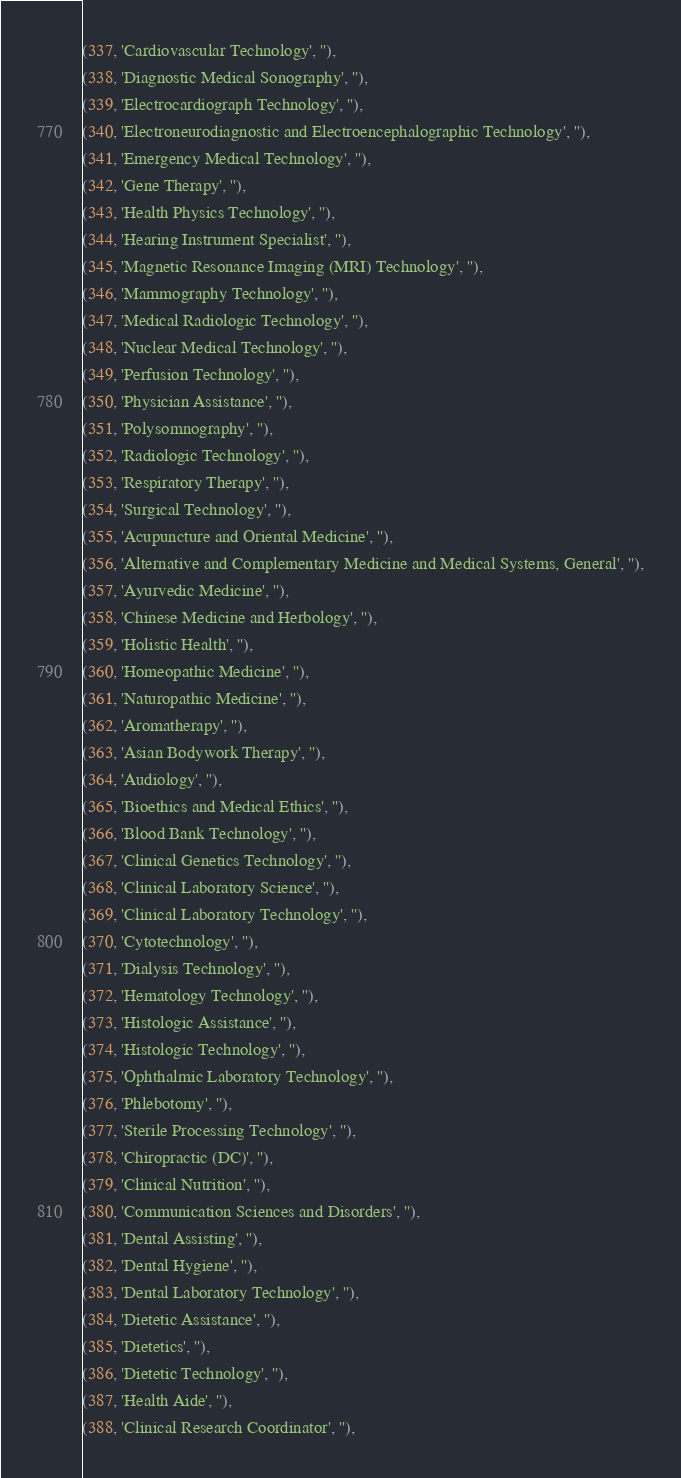Convert code to text. <code><loc_0><loc_0><loc_500><loc_500><_SQL_>(337, 'Cardiovascular Technology', ''),
(338, 'Diagnostic Medical Sonography', ''),
(339, 'Electrocardiograph Technology', ''),
(340, 'Electroneurodiagnostic and Electroencephalographic Technology', ''),
(341, 'Emergency Medical Technology', ''),
(342, 'Gene Therapy', ''),
(343, 'Health Physics Technology', ''),
(344, 'Hearing Instrument Specialist', ''),
(345, 'Magnetic Resonance Imaging (MRI) Technology', ''),
(346, 'Mammography Technology', ''),
(347, 'Medical Radiologic Technology', ''),
(348, 'Nuclear Medical Technology', ''),
(349, 'Perfusion Technology', ''),
(350, 'Physician Assistance', ''),
(351, 'Polysomnography', ''),
(352, 'Radiologic Technology', ''),
(353, 'Respiratory Therapy', ''),
(354, 'Surgical Technology', ''),
(355, 'Acupuncture and Oriental Medicine', ''),
(356, 'Alternative and Complementary Medicine and Medical Systems, General', ''),
(357, 'Ayurvedic Medicine', ''),
(358, 'Chinese Medicine and Herbology', ''),
(359, 'Holistic Health', ''),
(360, 'Homeopathic Medicine', ''),
(361, 'Naturopathic Medicine', ''),
(362, 'Aromatherapy', ''),
(363, 'Asian Bodywork Therapy', ''),
(364, 'Audiology', ''),
(365, 'Bioethics and Medical Ethics', ''),
(366, 'Blood Bank Technology', ''),
(367, 'Clinical Genetics Technology', ''),
(368, 'Clinical Laboratory Science', ''),
(369, 'Clinical Laboratory Technology', ''),
(370, 'Cytotechnology', ''),
(371, 'Dialysis Technology', ''),
(372, 'Hematology Technology', ''),
(373, 'Histologic Assistance', ''),
(374, 'Histologic Technology', ''),
(375, 'Ophthalmic Laboratory Technology', ''),
(376, 'Phlebotomy', ''),
(377, 'Sterile Processing Technology', ''),
(378, 'Chiropractic (DC)', ''),
(379, 'Clinical Nutrition', ''),
(380, 'Communication Sciences and Disorders', ''),
(381, 'Dental Assisting', ''),
(382, 'Dental Hygiene', ''),
(383, 'Dental Laboratory Technology', ''),
(384, 'Dietetic Assistance', ''),
(385, 'Dietetics', ''),
(386, 'Dietetic Technology', ''),
(387, 'Health Aide', ''),
(388, 'Clinical Research Coordinator', ''),</code> 